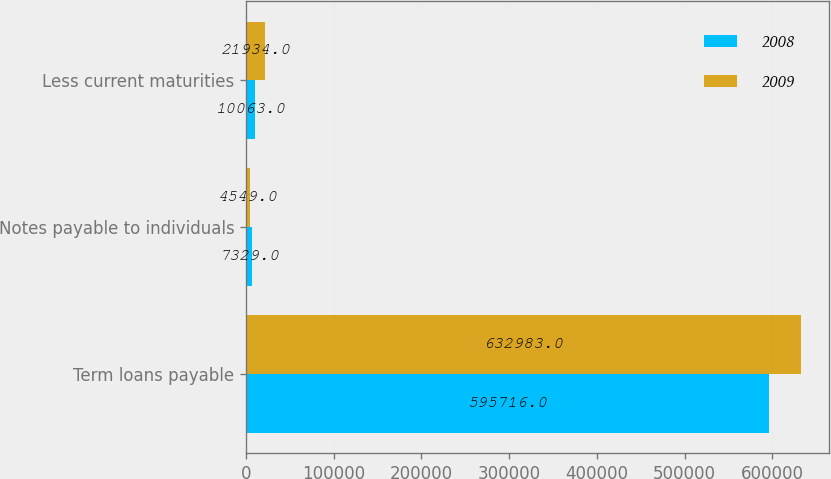<chart> <loc_0><loc_0><loc_500><loc_500><stacked_bar_chart><ecel><fcel>Term loans payable<fcel>Notes payable to individuals<fcel>Less current maturities<nl><fcel>2008<fcel>595716<fcel>7329<fcel>10063<nl><fcel>2009<fcel>632983<fcel>4549<fcel>21934<nl></chart> 